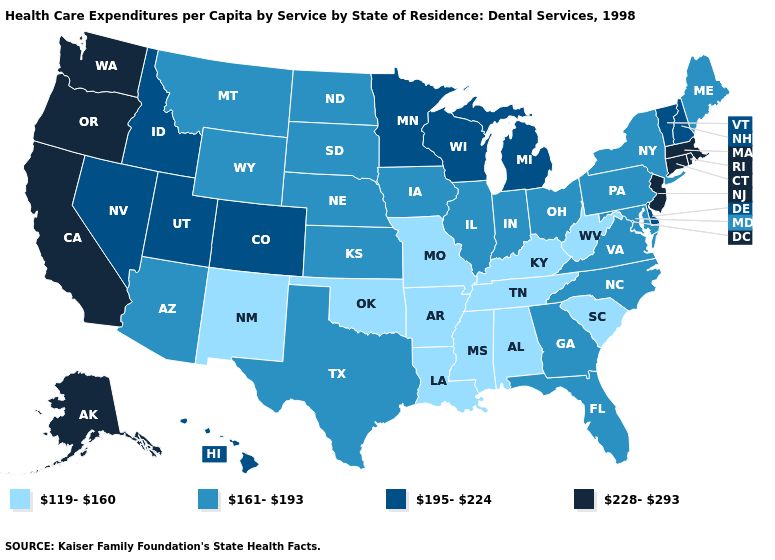Among the states that border Utah , which have the highest value?
Concise answer only. Colorado, Idaho, Nevada. Name the states that have a value in the range 228-293?
Concise answer only. Alaska, California, Connecticut, Massachusetts, New Jersey, Oregon, Rhode Island, Washington. Among the states that border Virginia , does North Carolina have the lowest value?
Keep it brief. No. What is the highest value in the West ?
Give a very brief answer. 228-293. Name the states that have a value in the range 195-224?
Keep it brief. Colorado, Delaware, Hawaii, Idaho, Michigan, Minnesota, Nevada, New Hampshire, Utah, Vermont, Wisconsin. Does Utah have the highest value in the West?
Concise answer only. No. What is the value of Indiana?
Keep it brief. 161-193. What is the value of Vermont?
Quick response, please. 195-224. Which states hav the highest value in the South?
Keep it brief. Delaware. Name the states that have a value in the range 195-224?
Be succinct. Colorado, Delaware, Hawaii, Idaho, Michigan, Minnesota, Nevada, New Hampshire, Utah, Vermont, Wisconsin. Does the first symbol in the legend represent the smallest category?
Keep it brief. Yes. What is the highest value in the Northeast ?
Give a very brief answer. 228-293. Among the states that border Idaho , which have the highest value?
Keep it brief. Oregon, Washington. What is the value of Wisconsin?
Answer briefly. 195-224. 